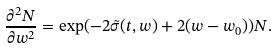Convert formula to latex. <formula><loc_0><loc_0><loc_500><loc_500>\frac { \partial ^ { 2 } N } { \partial w ^ { 2 } } = \exp ( - 2 \tilde { \sigma } ( t , w ) + 2 ( w - w _ { 0 } ) ) N .</formula> 